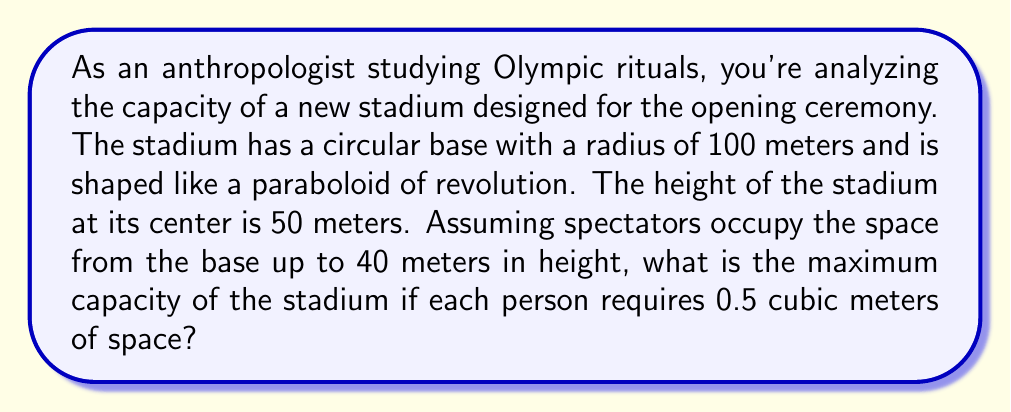Can you solve this math problem? To solve this problem, we need to follow these steps:

1. Calculate the volume of the paraboloid section up to 40 meters:
   The volume of a paraboloid of revolution is given by the formula:
   $$V = \frac{1}{2}\pi r^2 h$$
   where $r$ is the radius of the base and $h$ is the height.

   For our stadium up to 40 meters:
   $$V_{40} = \frac{1}{2}\pi (100\text{ m})^2 (40\text{ m}) = 628,318.53\text{ m}^3$$

2. Calculate the volume of the entire paraboloid (up to 50 meters):
   $$V_{50} = \frac{1}{2}\pi (100\text{ m})^2 (50\text{ m}) = 785,398.16\text{ m}^3$$

3. Calculate the volume occupied by spectators:
   $$V_\text{spectators} = V_{50} - V_{40} = 785,398.16 - 628,318.53 = 157,079.63\text{ m}^3$$

4. Calculate the maximum number of spectators:
   Each person requires 0.5 cubic meters, so:
   $$\text{Number of spectators} = \frac{V_\text{spectators}}{0.5\text{ m}^3/\text{person}} = \frac{157,079.63\text{ m}^3}{0.5\text{ m}^3/\text{person}} = 314,159.26$$

5. Round down to the nearest whole number:
   Maximum capacity = 314,159 people
Answer: 314,159 people 